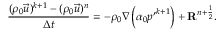Convert formula to latex. <formula><loc_0><loc_0><loc_500><loc_500>\frac { ( \rho _ { 0 } \vec { u } ) ^ { k + 1 } - ( \rho _ { 0 } \vec { u } ) ^ { n } } { \Delta t } = - \rho _ { 0 } \nabla \left ( \alpha _ { 0 } { p ^ { \prime } } ^ { k + 1 } \right ) + R ^ { n + \frac { 1 } { 2 } } .</formula> 